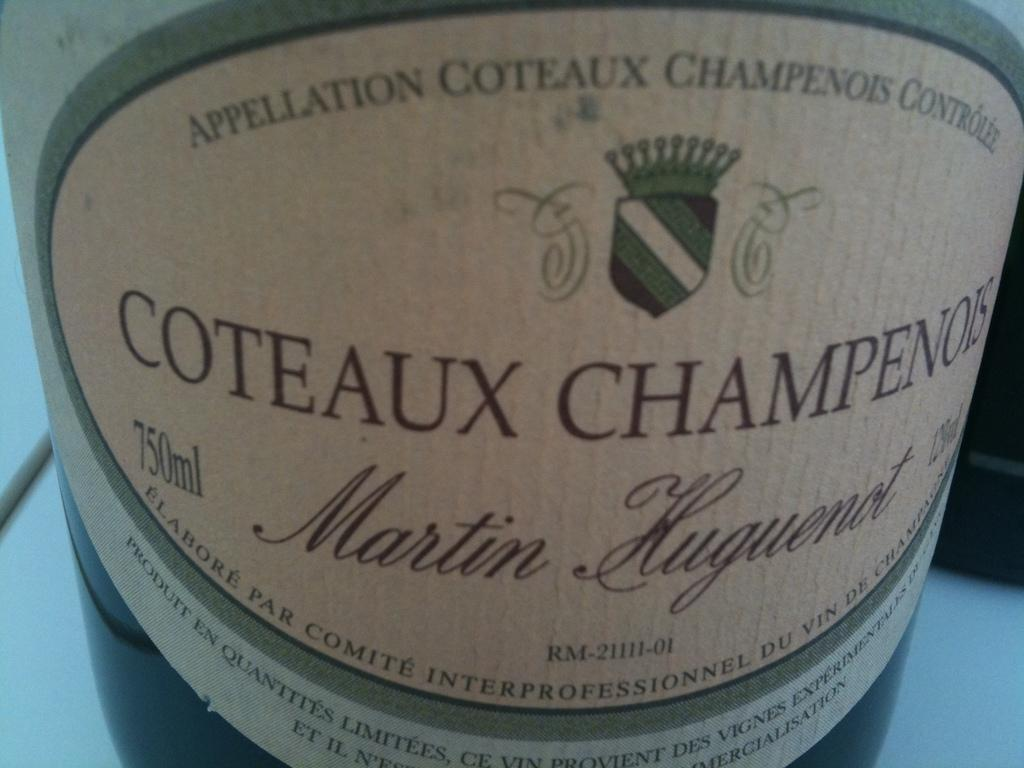<image>
Relay a brief, clear account of the picture shown. a small container with the word Martin on it 